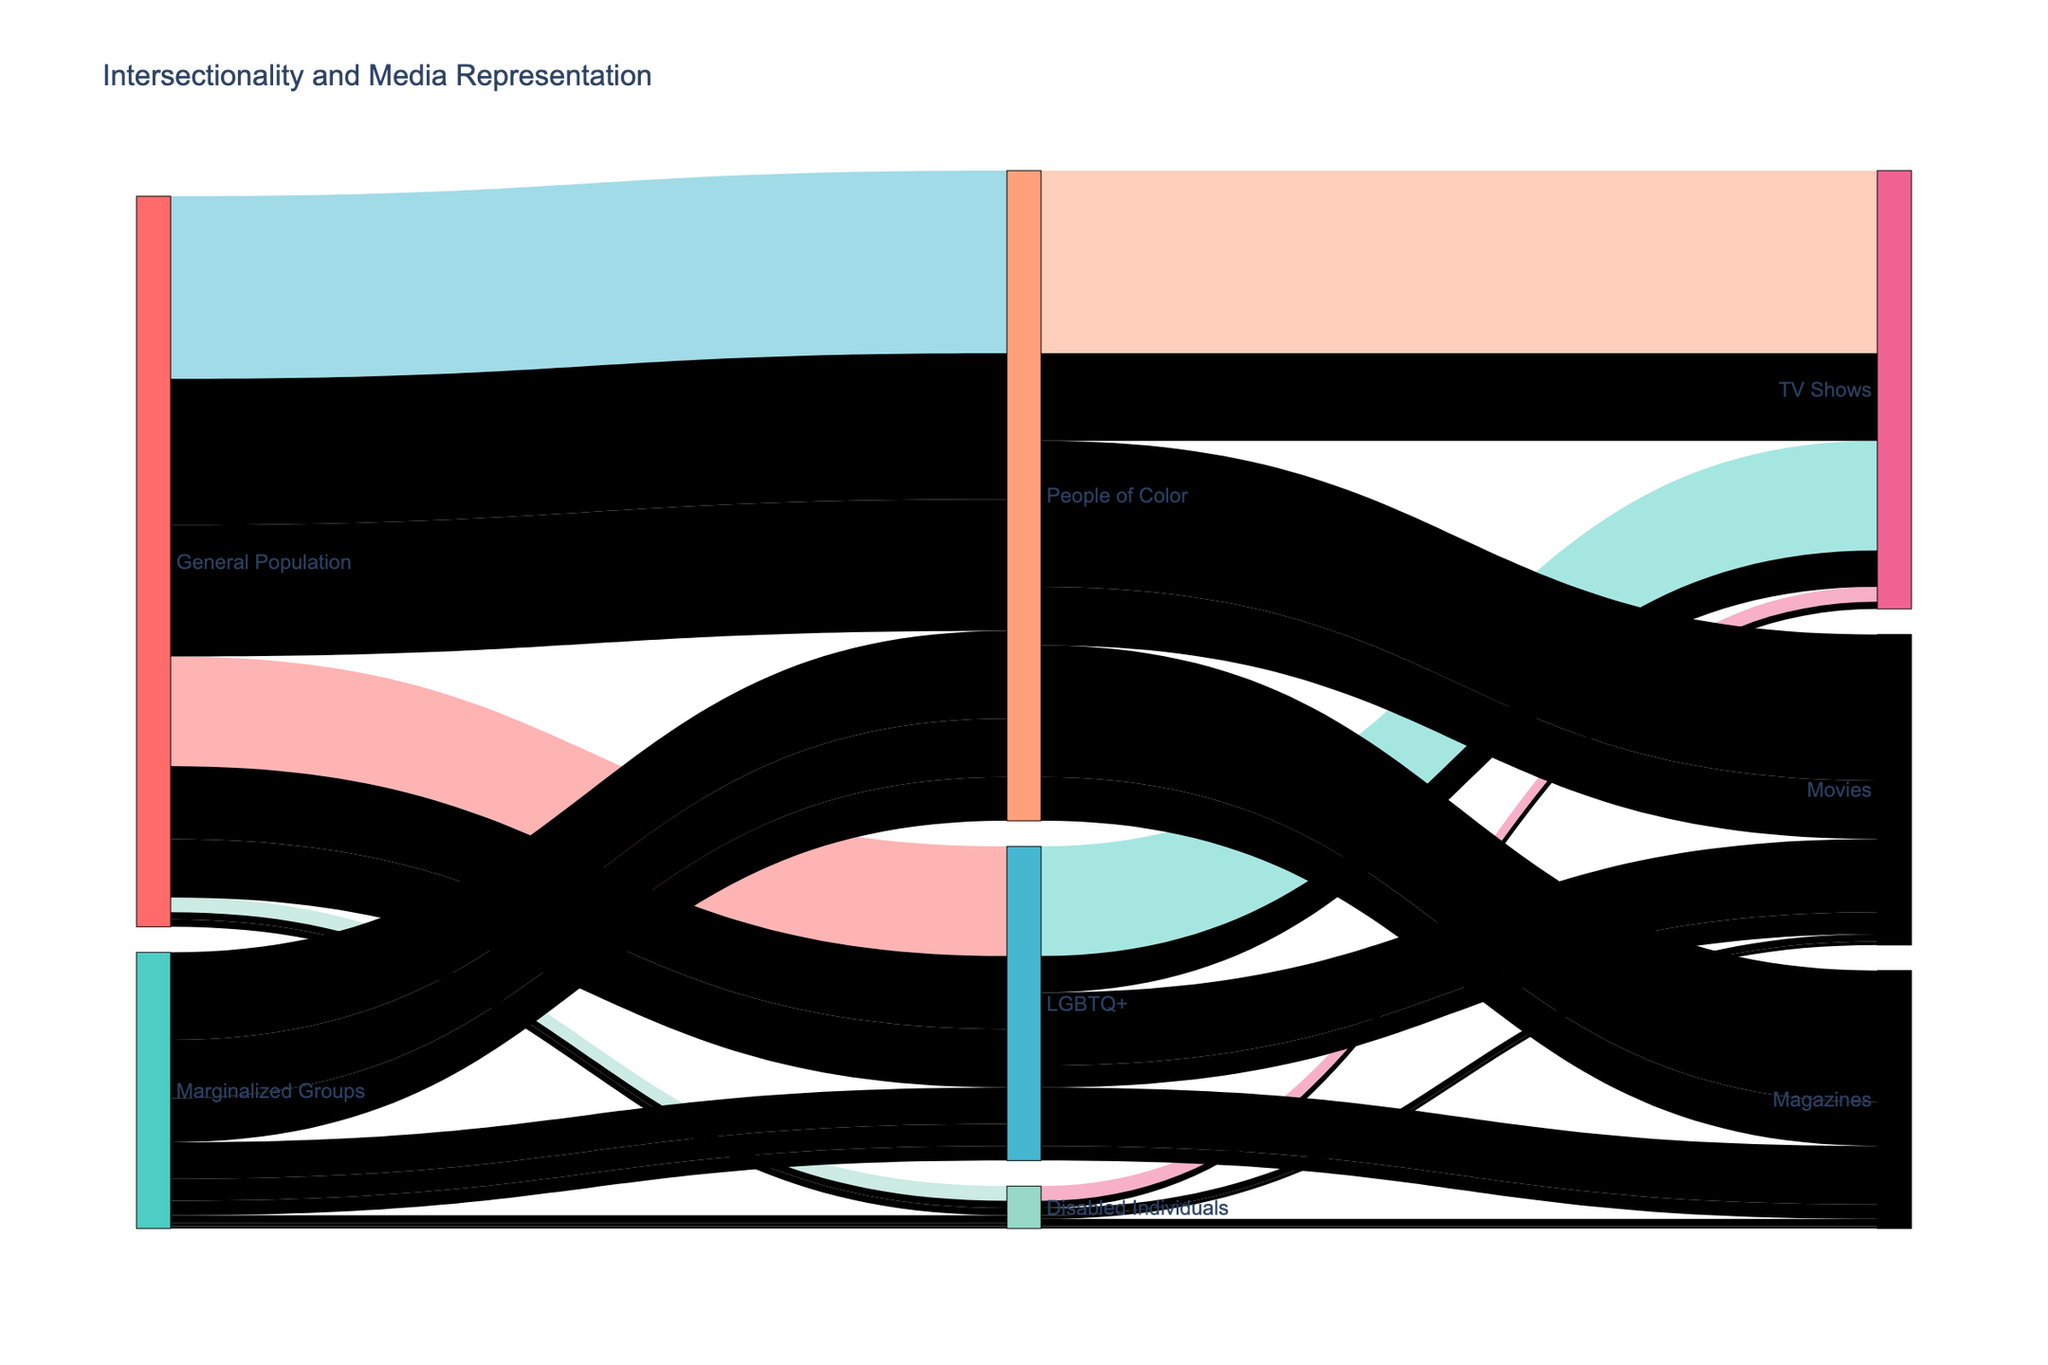What is the percentage of representation for People of Color in TV Shows from the General Population? The figure shows a flow from the General Population to People of Color and then to TV Shows, with the percentage attached to the link being the representation percentage. In this case, it's 25.
Answer: 25% What is the total percentage of representation for Disabled Individuals in all forms of media from the Marginalized Groups? To find the total percentage, add the representation percentages of Disabled Individuals in TV Shows, Movies, and Magazines from the Marginalized Groups. That is 1 (TV Shows) + 0.5 (Movies) + 0.3 (Magazines) = 1.8.
Answer: 1.8% How does the representation percentage of LGBTQ+ individuals in Movies compare between the General Population and Marginalized Groups? Both percentages are displayed in the figure. For the General Population, the representation in Movies is 10%, while for the Marginalized Groups, it is 3%. By comparison, the General Population's percentage is higher.
Answer: General Population: 10%, Marginalized Groups: 3% Which group has the highest representation in TV Shows from the General Population, and what is the percentage? By looking at the flows under General Population to TV Shows, the group with the highest percentage is People of Color with 25%.
Answer: People of Color, 25% What's the difference in representation for People of Color in Magazines between the General Population and Marginalized Groups? For this comparison, refer to the flow percentages for People of Color in Magazines from both populations: 18% for the General Population and 6% for the Marginalized Groups. The difference is 18 - 6 = 12.
Answer: 12% What percentage of the total representation for People of Color in all media does their representation in Movies constitute from the General Population? First, sum the representation percentages for People of Color across TV Shows, Movies, and Magazines from the General Population (25 + 20 + 18 = 63). Then, calculate the percentage for Movies: (20/63) * 100 ≈ 31.75%.
Answer: Approximately 31.75% Is the representation of Disabled Individuals higher in Movies or Magazines from the General Population? The diagram shows the representation percentages for Disabled Individuals. For Movies and Magazines from the General Population, it is 1% each. Thus, the representation is equal.
Answer: Equal Which media type has the lowest representation of LGBTQ+ individuals from the Marginalized Groups? By examining the flow percentages, representation in Magazines for LGBTQ+ individuals from the Marginalized Groups has a percentage of 2%, which is the lowest among TV Shows, Movies, and Magazines.
Answer: Magazines What is the combined representation percentage in TV Shows for LGBTQ+ from both the General Population and Marginalized Groups? Sum the percentages of representation in TV Shows for LGBTQ+ from both populations: 15% (General Population) + 5% (Marginalized Groups) = 20%.
Answer: 20% How does the representation of People of Color in TV Shows compare to Disabled Individuals in TV Shows from the Marginalized Groups? Referencing the figure, People of Color have a representation percentage of 12% whereas Disabled Individuals have 1% in TV Shows from the Marginalized Groups. Therefore, People of Color have higher representation.
Answer: People of Color: 12%, Disabled Individuals: 1% 